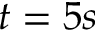Convert formula to latex. <formula><loc_0><loc_0><loc_500><loc_500>t = 5 s</formula> 